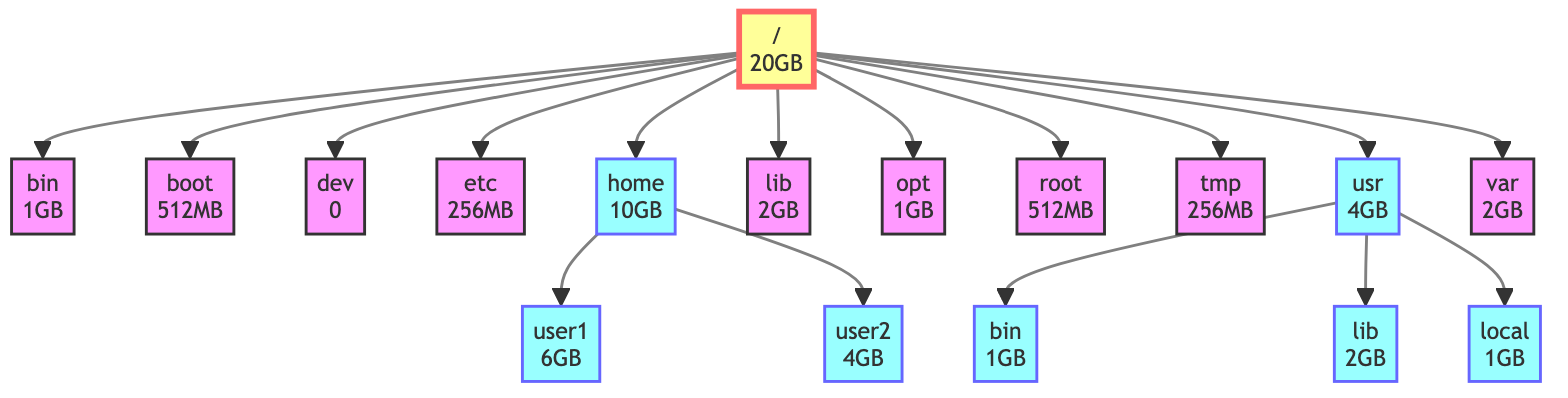What is the total disk space of the root directory? The root directory is represented by "/" in the diagram, which shows a total disk space of 20GB.
Answer: 20GB How much disk space does the "/etc" directory occupy? The "/etc" directory is directly labeled within the diagram with a value of 256MB.
Answer: 256MB Which subdirectory under "/home" has the larger disk space? By comparing the two subdirectories, "user1" with 6GB and "user2" with 4GB, it is clear that "user1" has the larger disk space.
Answer: user1 How many subdirectories are present in the "/usr" directory? The diagram shows three subdirectories under "/usr": "bin," "lib," and "local," making the total count three.
Answer: 3 What is the total disk space occupied by the "/usr" directory's subdirectories? The "/usr" directory contains three subdirectories: "bin" (1GB), "lib" (2GB), and "local" (1GB). Adding these values (1GB + 2GB + 1GB) totals to 4GB.
Answer: 4GB Which directory has no allocated disk space? The "/dev" directory is shown to have 0 allocated disk space in the diagram.
Answer: dev What is the total disk space allocated to user directories under "/home"? The total disk space for "user1" (6GB) and "user2" (4GB) is found by adding both values together, resulting in 10GB.
Answer: 10GB Which directory has more disk space: "/lib" or "/var"? The "/lib" directory shows 2GB of disk space, and the "/var" directory also shows 2GB. They have equal disk space.
Answer: equal What is the disk space of the "/boot" directory? The "/boot" directory is labeled with a total disk space of 512MB in the diagram.
Answer: 512MB 